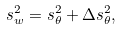<formula> <loc_0><loc_0><loc_500><loc_500>s ^ { 2 } _ { w } = s ^ { 2 } _ { \theta } + \Delta s ^ { 2 } _ { \theta } ,</formula> 